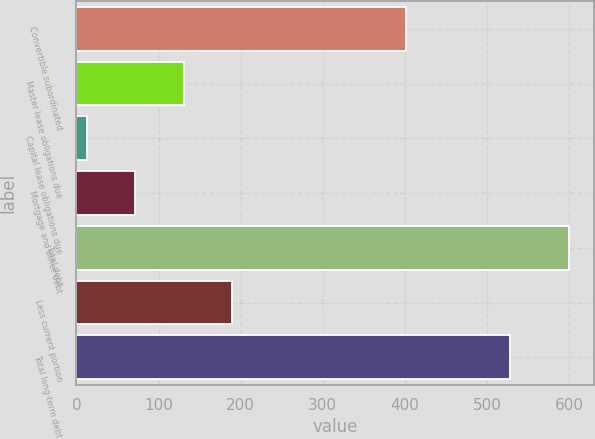Convert chart. <chart><loc_0><loc_0><loc_500><loc_500><bar_chart><fcel>Convertible subordinated<fcel>Master lease obligations due<fcel>Capital lease obligations due<fcel>Mortgage and other debt<fcel>Total debt<fcel>Less current portion<fcel>Total long-term debt<nl><fcel>402<fcel>130.4<fcel>13<fcel>71.7<fcel>600<fcel>189.1<fcel>528<nl></chart> 